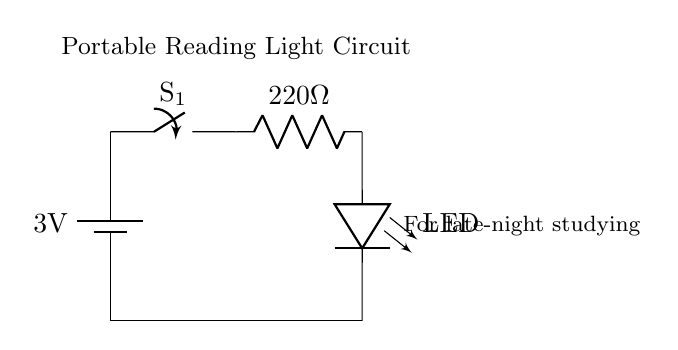What is the voltage of this circuit? The voltage of the circuit is 3 volts, indicated by the battery's label in the diagram.
Answer: 3 volts What is the function of the switch? The switch is used to open or close the circuit, allowing for the control of current flow when it is turned on or off.
Answer: Control current flow What is the resistance value in this circuit? The resistance in the circuit is 220 ohms, as labeled next to the resistor component in the diagram.
Answer: 220 ohms How many components are in this circuit? There are four components in this circuit: one battery, one switch, one resistor, and one LED.
Answer: Four What would happen if the resistor were removed? If the resistor were removed, it would cause excessive current to flow to the LED, likely burning it out and damaging the circuit.
Answer: LED damage What is the purpose of the LED in this circuit? The purpose of the LED is to provide light for reading during late-night study sessions, hence the term "portable reading light."
Answer: Provide light 